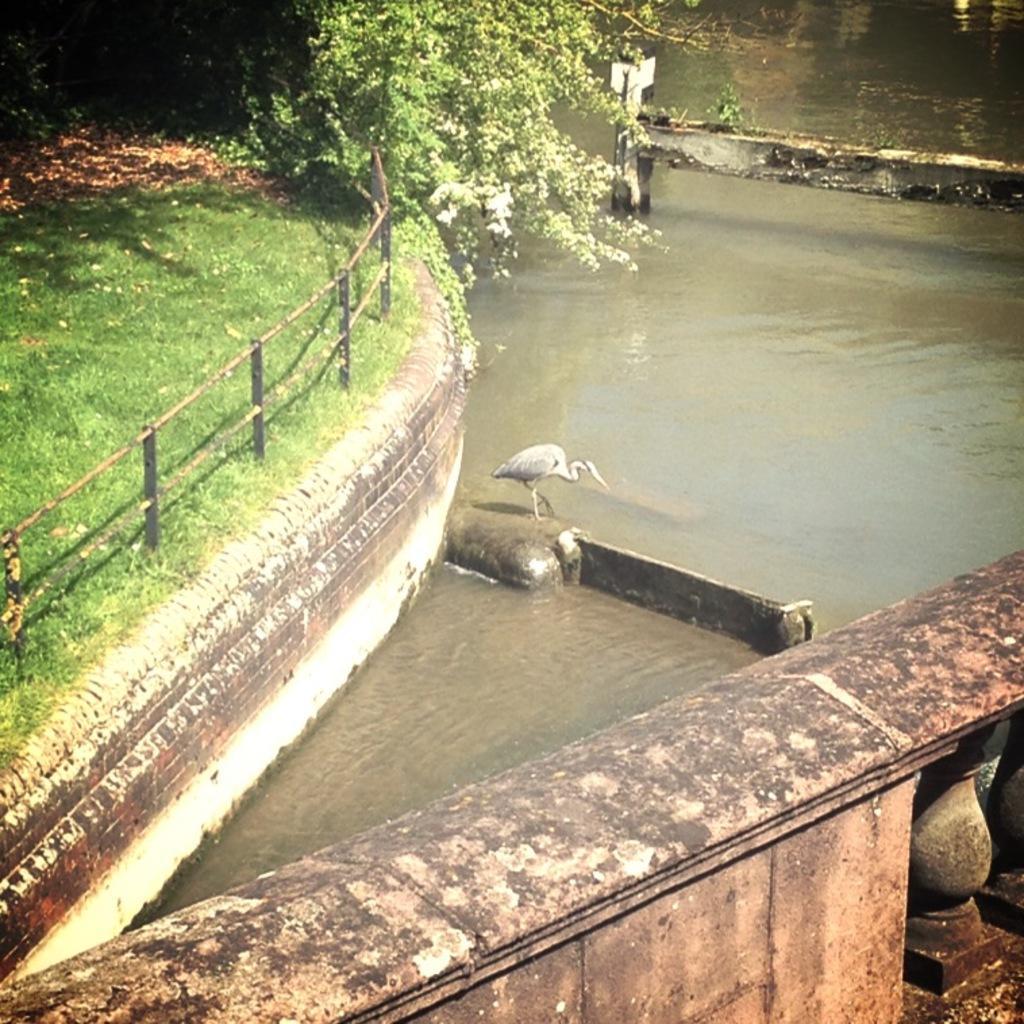Please provide a concise description of this image. This picture is clicked outside. In the foreground we can see a railing like object. In the center we can see a bird standing on the rock and we can see some objects in the water body. On the left we can see the metal rods, green grass, plants. In the background we can see the plants and some objects. 